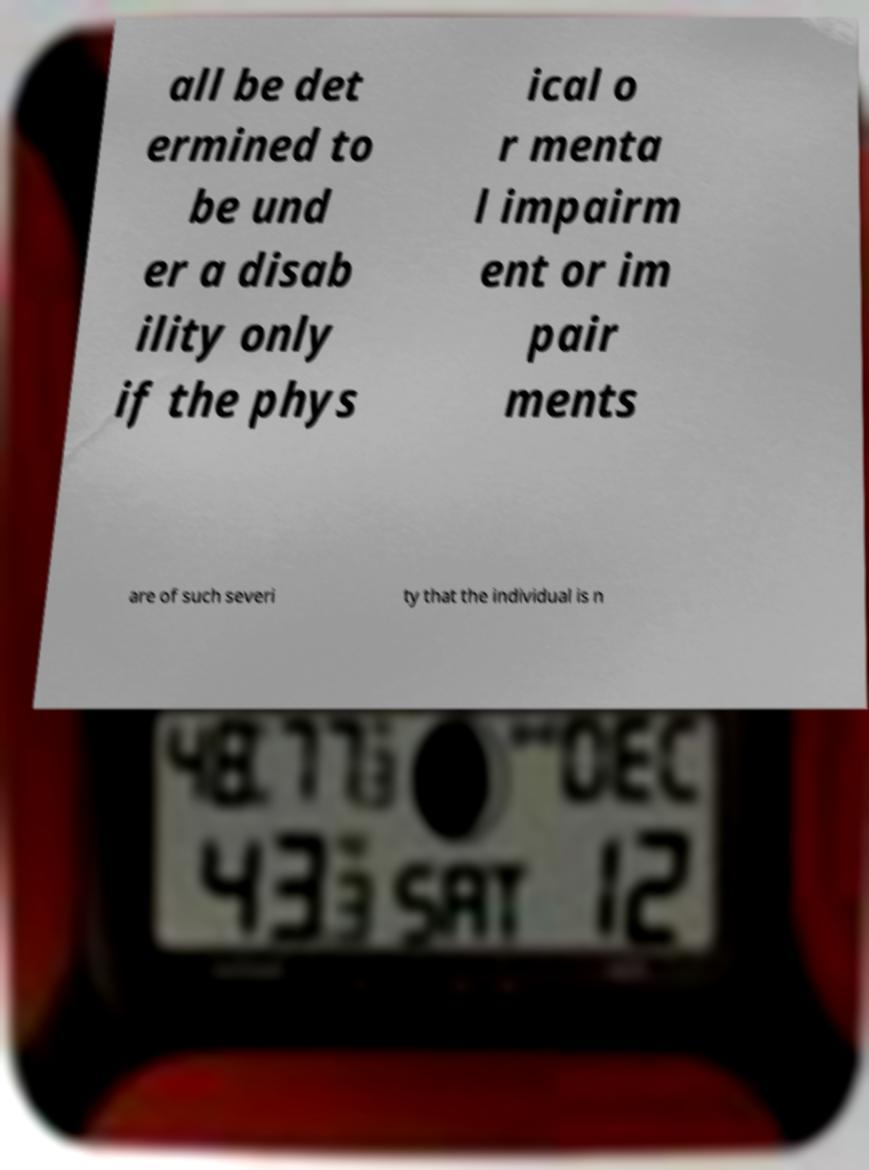I need the written content from this picture converted into text. Can you do that? all be det ermined to be und er a disab ility only if the phys ical o r menta l impairm ent or im pair ments are of such severi ty that the individual is n 